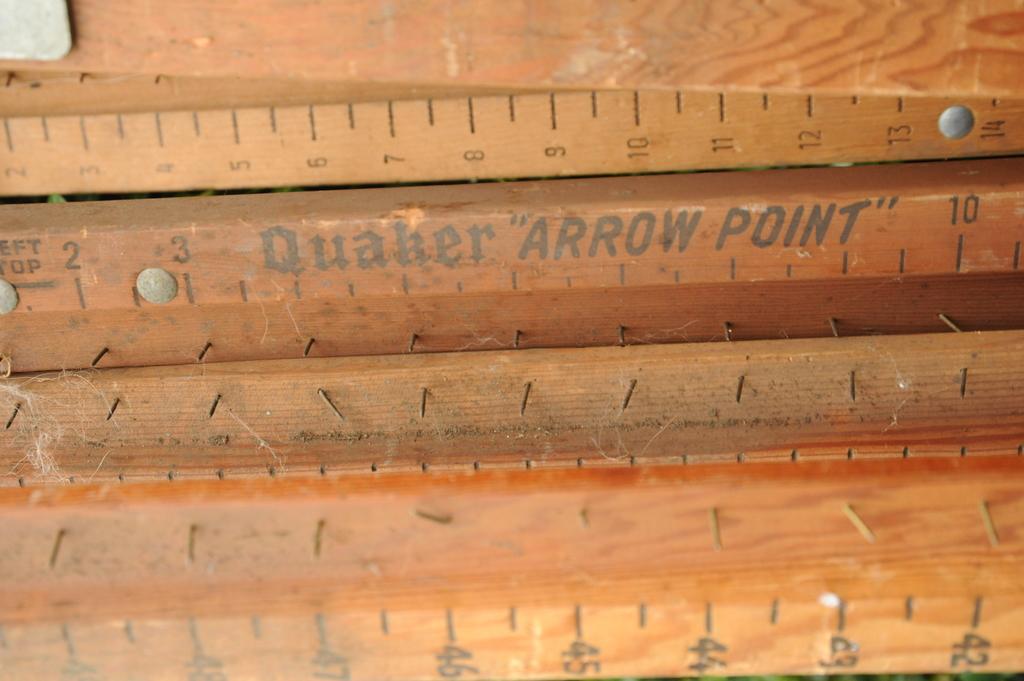What company made the ruler?
Your answer should be very brief. Quaker. 